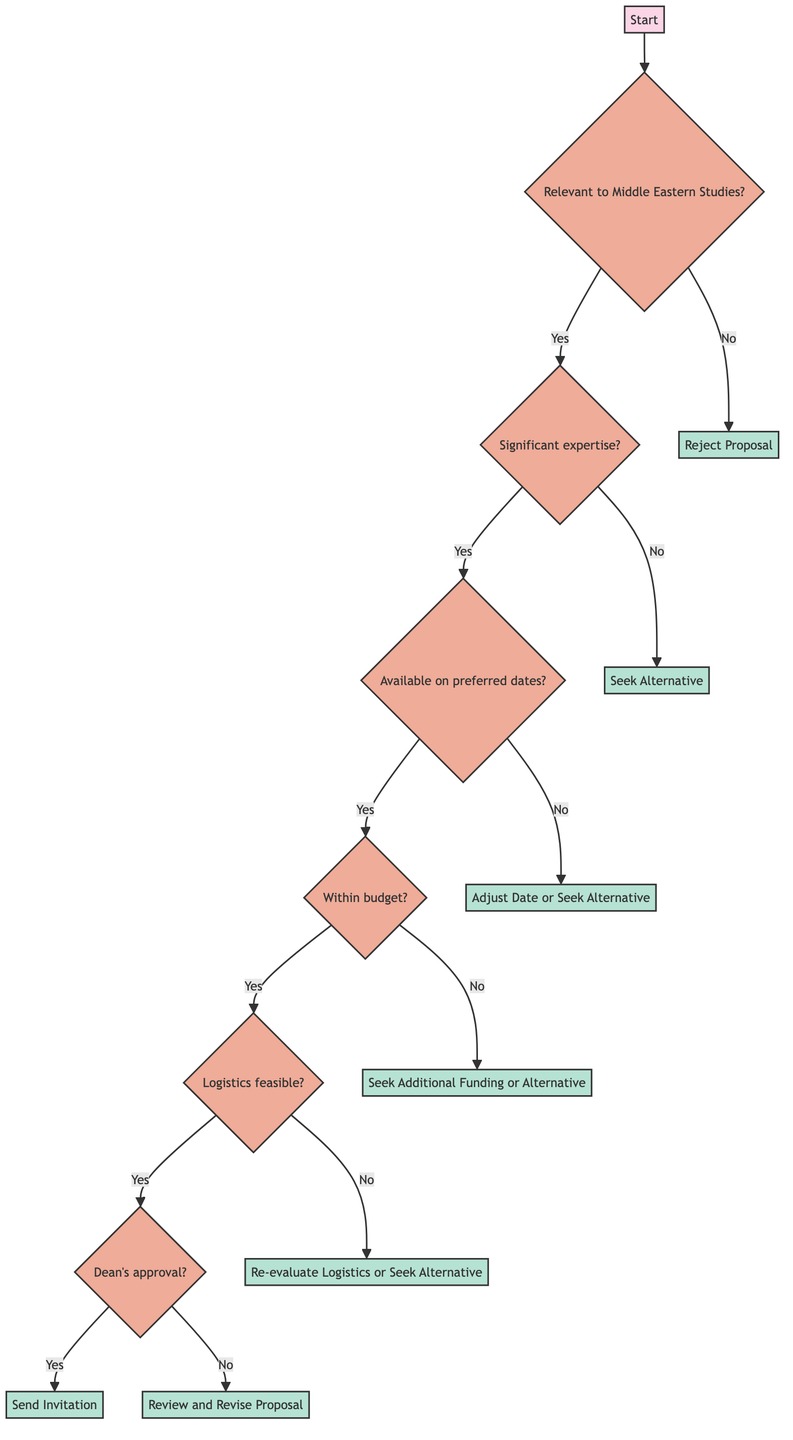What is the first question in the diagram? The first question in the diagram is whether the guest speaker or panelist is relevant to Middle Eastern Studies. This is represented by the node labeled "Relevant to Middle Eastern Studies?" attached to the "Start" node.
Answer: Is the guest speaker or panelist relevant to Middle Eastern Studies? How many nodes are present in the decision tree? The diagram contains a total of 10 nodes, including both decision nodes and endpoint nodes, starting from the "Start" node and ending with possible outcomes like "Reject Proposal" or "Send Invitation."
Answer: 10 What happens if the speaker does not have significant expertise? If the speaker does not have significant expertise in Middle Eastern Studies, the process directs to "Seek Alternative." This is shown as an endpoint following the decision node that asks about the speaker’s expertise.
Answer: Seek Alternative What is checked after confirming the speaker's availability? After confirming that the speaker is available during the preferred dates, the next step is to assess the budget to see if the department can accommodate the speaker's fees and related expenses.
Answer: Budget Consideration If the logistical arrangements are not feasible, what is the next step? If the logistical arrangements regarding venue, travel, and accommodation are not feasible, the process directs to "Re-evaluate Logistics or Seek Alternative." This shows a re-evaluation step before making further decisions.
Answer: Re-evaluate Logistics or Seek Alternative In the case of budget constraints, what action is suggested? If the budget cannot accommodate the speaker's fees and related expenses, the diagram suggests seeking additional funding or considering an alternative speaker, indicating a need for financial reassessment.
Answer: Seek Additional Funding or Alternative What determines whether an invitation is sent? The invitation is sent only if the Dean or relevant authority approves the invitation. This shows that institutional approval is necessary before finalizing the guest speaker's invitation.
Answer: Send Invitation What is the final decision point in the tree? The final decision point in the tree is whether the Dean or relevant authority approves the invitation, which leads to either sending the invitation or reviewing and revising the proposal.
Answer: Dean's approval 